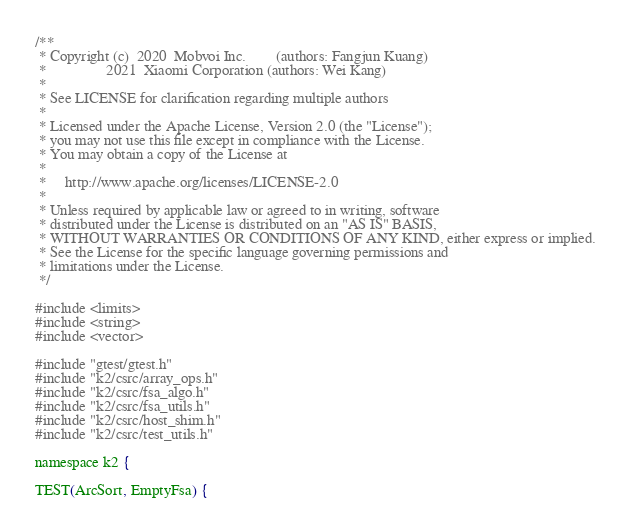<code> <loc_0><loc_0><loc_500><loc_500><_Cuda_>/**
 * Copyright (c)  2020  Mobvoi Inc.        (authors: Fangjun Kuang)
 *                2021  Xiaomi Corporation (authors: Wei Kang)
 *
 * See LICENSE for clarification regarding multiple authors
 *
 * Licensed under the Apache License, Version 2.0 (the "License");
 * you may not use this file except in compliance with the License.
 * You may obtain a copy of the License at
 *
 *     http://www.apache.org/licenses/LICENSE-2.0
 *
 * Unless required by applicable law or agreed to in writing, software
 * distributed under the License is distributed on an "AS IS" BASIS,
 * WITHOUT WARRANTIES OR CONDITIONS OF ANY KIND, either express or implied.
 * See the License for the specific language governing permissions and
 * limitations under the License.
 */

#include <limits>
#include <string>
#include <vector>

#include "gtest/gtest.h"
#include "k2/csrc/array_ops.h"
#include "k2/csrc/fsa_algo.h"
#include "k2/csrc/fsa_utils.h"
#include "k2/csrc/host_shim.h"
#include "k2/csrc/test_utils.h"

namespace k2 {

TEST(ArcSort, EmptyFsa) {</code> 